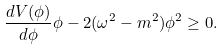<formula> <loc_0><loc_0><loc_500><loc_500>\frac { d V ( \phi ) } { d \phi } \phi - 2 ( \omega ^ { 2 } - m ^ { 2 } ) \phi ^ { 2 } \geq 0 .</formula> 